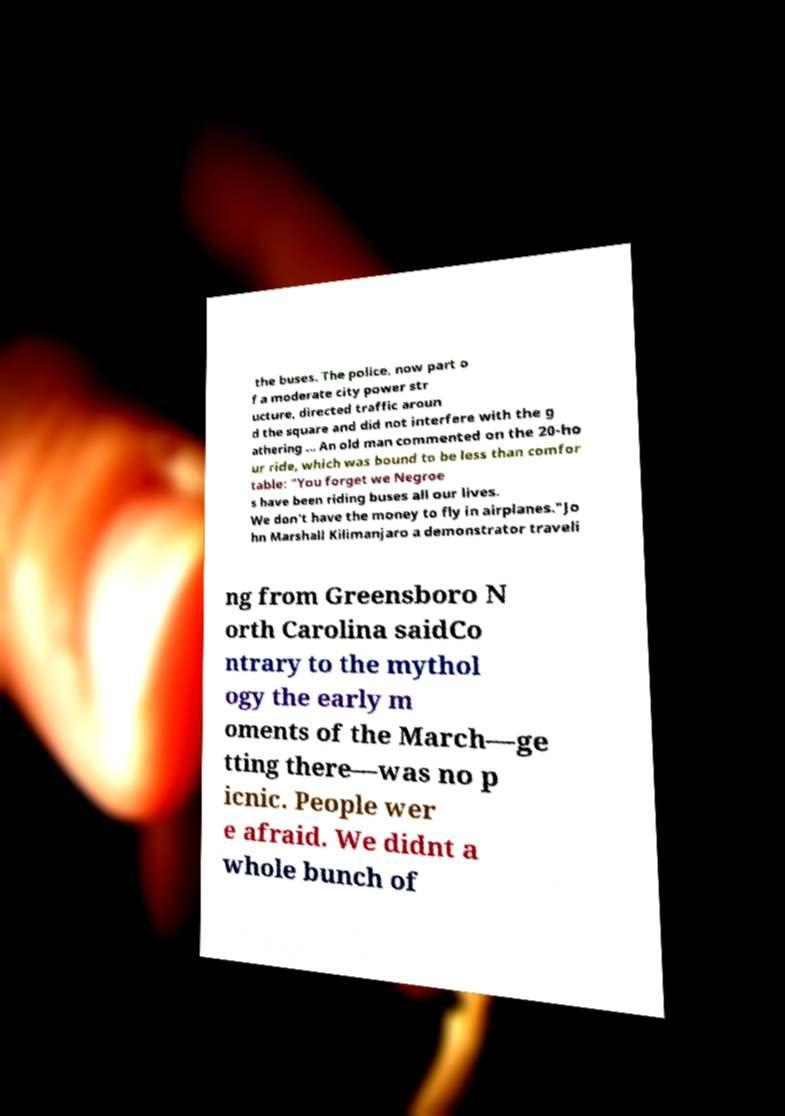There's text embedded in this image that I need extracted. Can you transcribe it verbatim? the buses. The police, now part o f a moderate city power str ucture, directed traffic aroun d the square and did not interfere with the g athering ... An old man commented on the 20-ho ur ride, which was bound to be less than comfor table: "You forget we Negroe s have been riding buses all our lives. We don't have the money to fly in airplanes."Jo hn Marshall Kilimanjaro a demonstrator traveli ng from Greensboro N orth Carolina saidCo ntrary to the mythol ogy the early m oments of the March—ge tting there—was no p icnic. People wer e afraid. We didnt a whole bunch of 